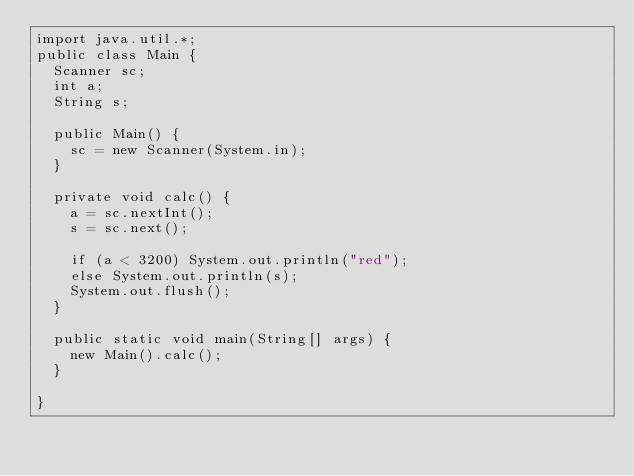<code> <loc_0><loc_0><loc_500><loc_500><_Java_>import java.util.*;
public class Main {
	Scanner sc;
	int a;
	String s;

	public Main() {
		sc = new Scanner(System.in);
	}
	
	private void calc() {
		a = sc.nextInt();
		s = sc.next();
		
		if (a < 3200) System.out.println("red");
		else System.out.println(s);
		System.out.flush();
	}

	public static void main(String[] args) {
		new Main().calc();
	}

}</code> 